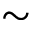Convert formula to latex. <formula><loc_0><loc_0><loc_500><loc_500>\sim</formula> 